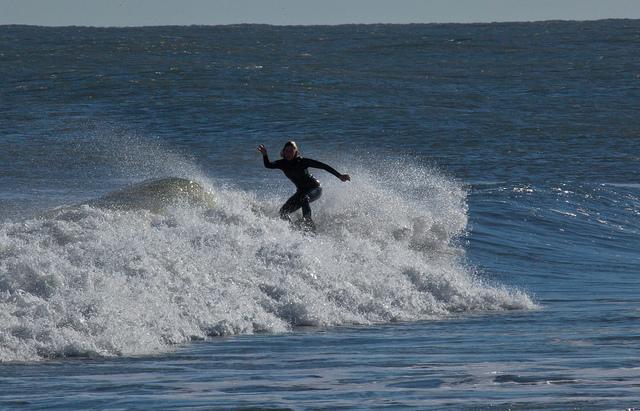Does this man have long hair?
Short answer required. Yes. Do you see the arms of the person?
Concise answer only. Yes. How many people are in the shot?
Keep it brief. 1. Are animals shown?
Quick response, please. No. How is this person going so fast?
Concise answer only. Waves. Is this guy a footer?
Short answer required. No. Is the person water or snow skiing?
Write a very short answer. Water. Can you see the shore?
Give a very brief answer. No. Is the person wearing a wetsuit?
Answer briefly. Yes. 